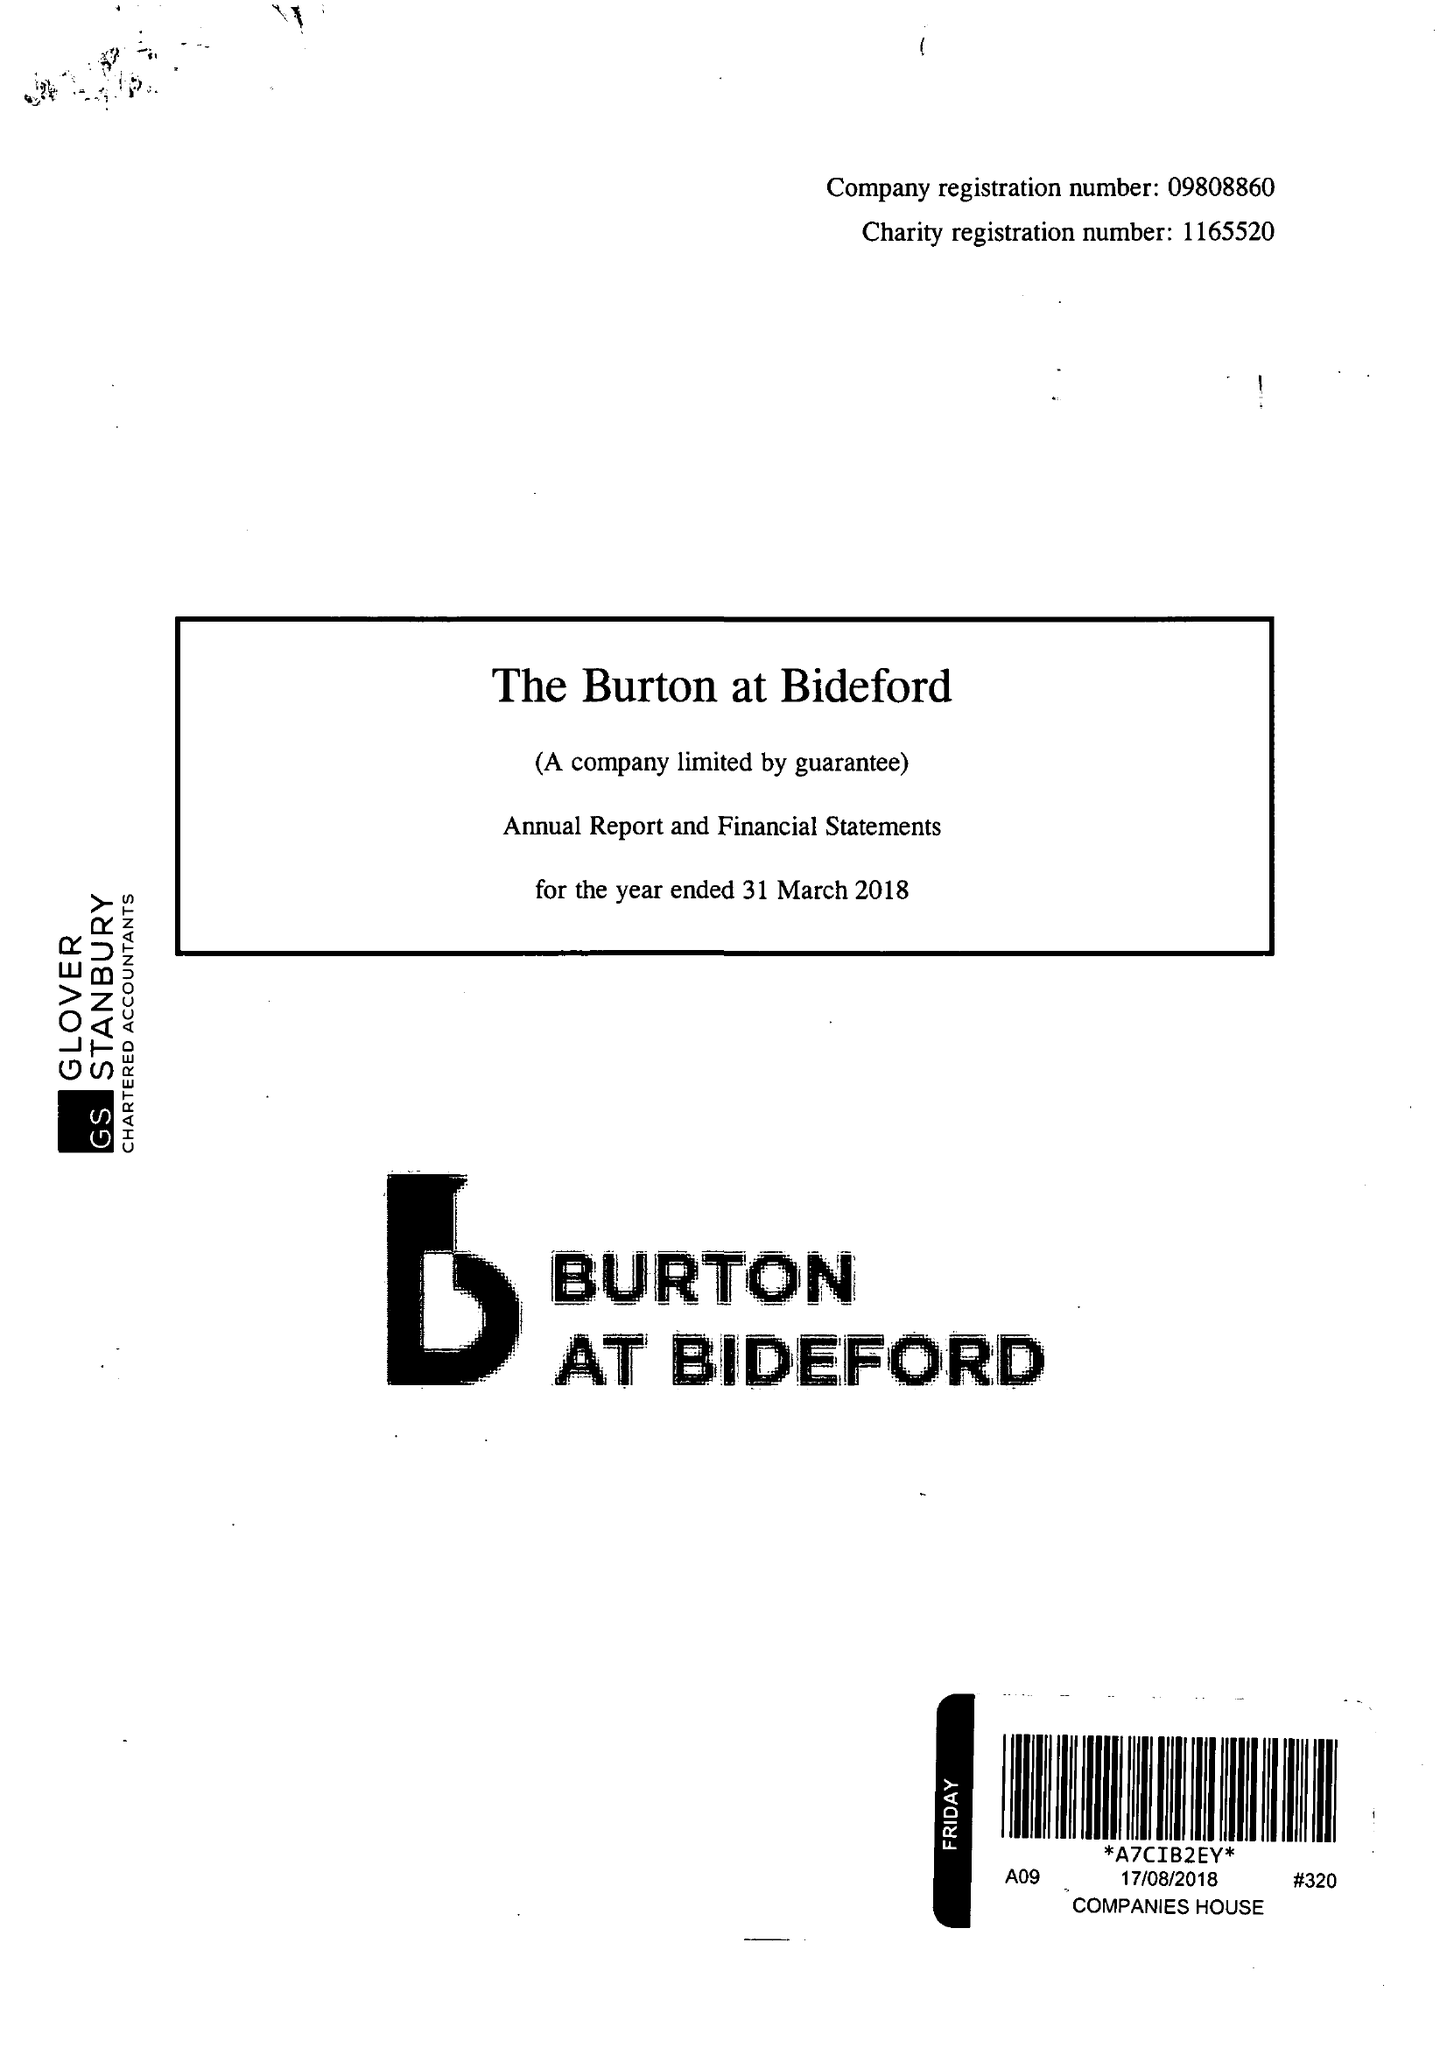What is the value for the address__post_town?
Answer the question using a single word or phrase. BIDEFORD 